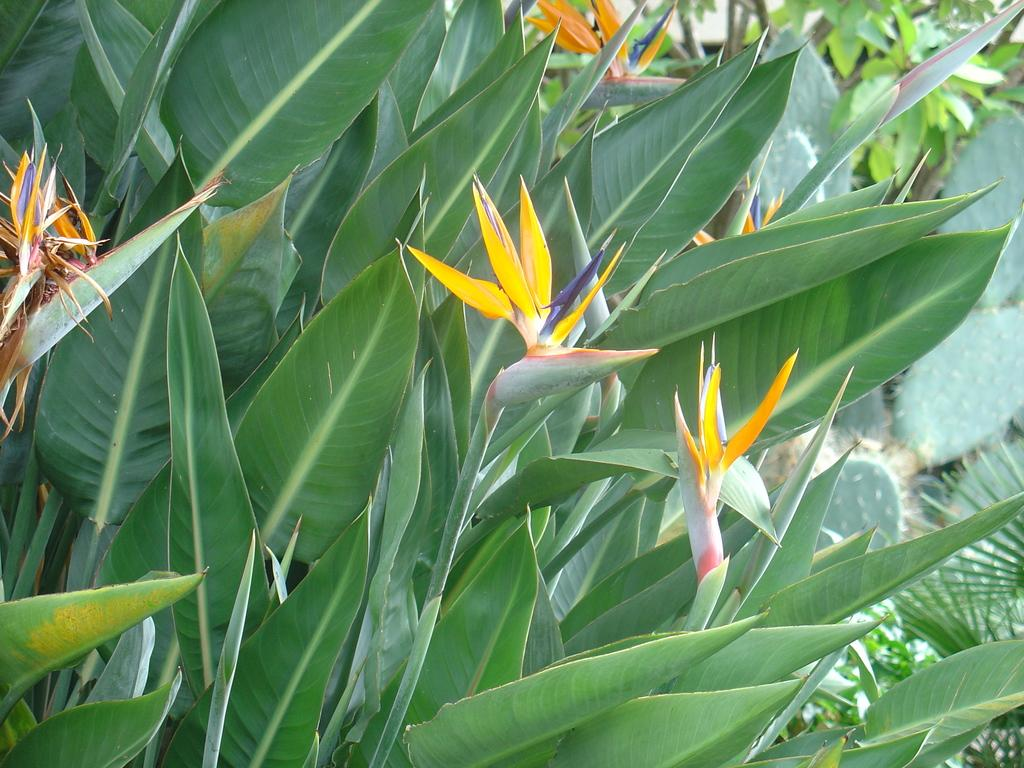What type of living organisms can be seen in the image? Plants can be seen in the image. What specific feature of the plants is visible? The plants have flowers. What type of punishment is being administered to the plants in the image? There is no punishment being administered to the plants in the image; they are simply growing and displaying their flowers. 